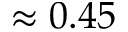<formula> <loc_0><loc_0><loc_500><loc_500>\approx 0 . 4 5</formula> 